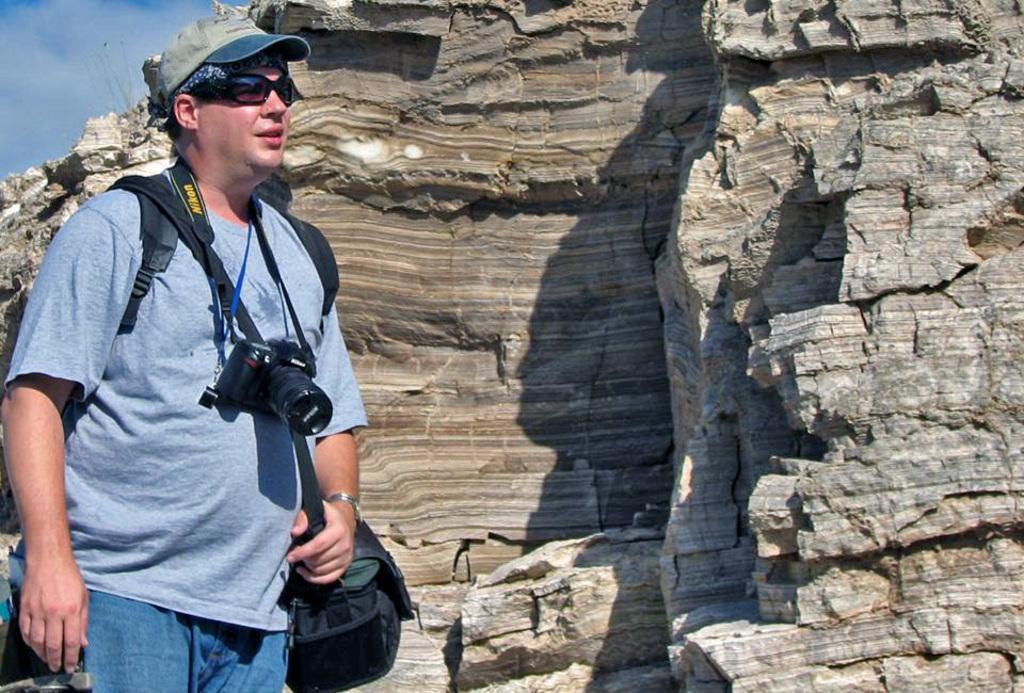In one or two sentences, can you explain what this image depicts? In this picture there is a person standing. He wore camera,backpack,cap and glasses. In this background we can see rock. There is sky with cloud. 